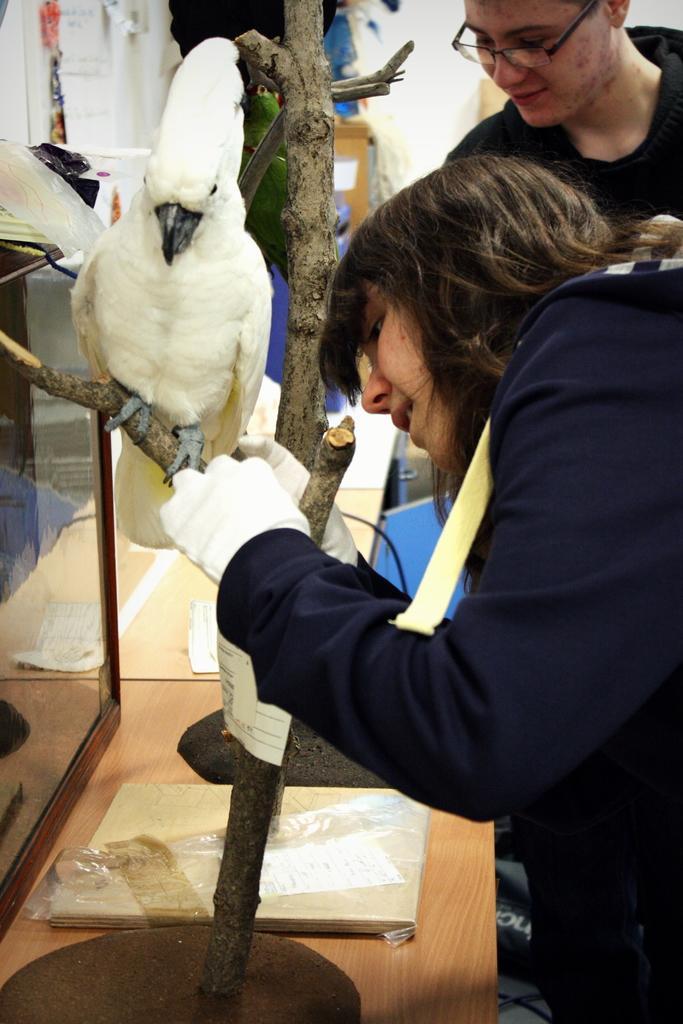Please provide a concise description of this image. In this image there are two people. On the left we can see a bird on the branch. At the bottom there is a table and we can see a box and a cover placed on the table. In the background there is a wall and some things. 